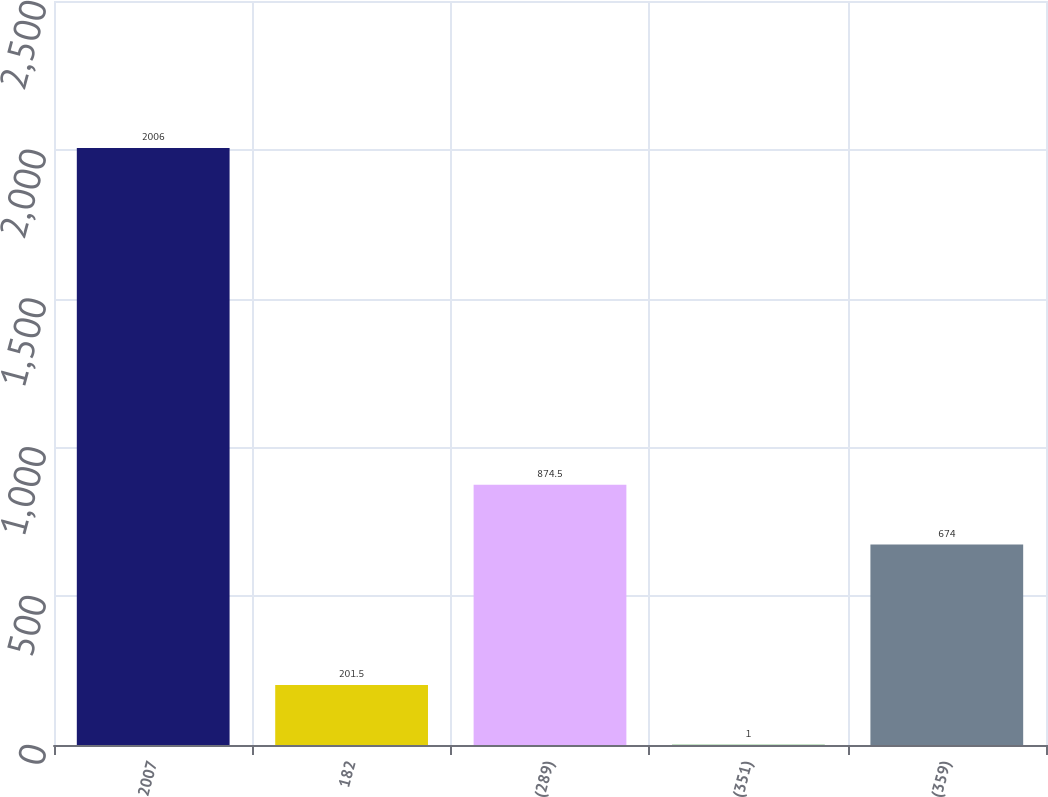<chart> <loc_0><loc_0><loc_500><loc_500><bar_chart><fcel>2007<fcel>182<fcel>(289)<fcel>(351)<fcel>(359)<nl><fcel>2006<fcel>201.5<fcel>874.5<fcel>1<fcel>674<nl></chart> 